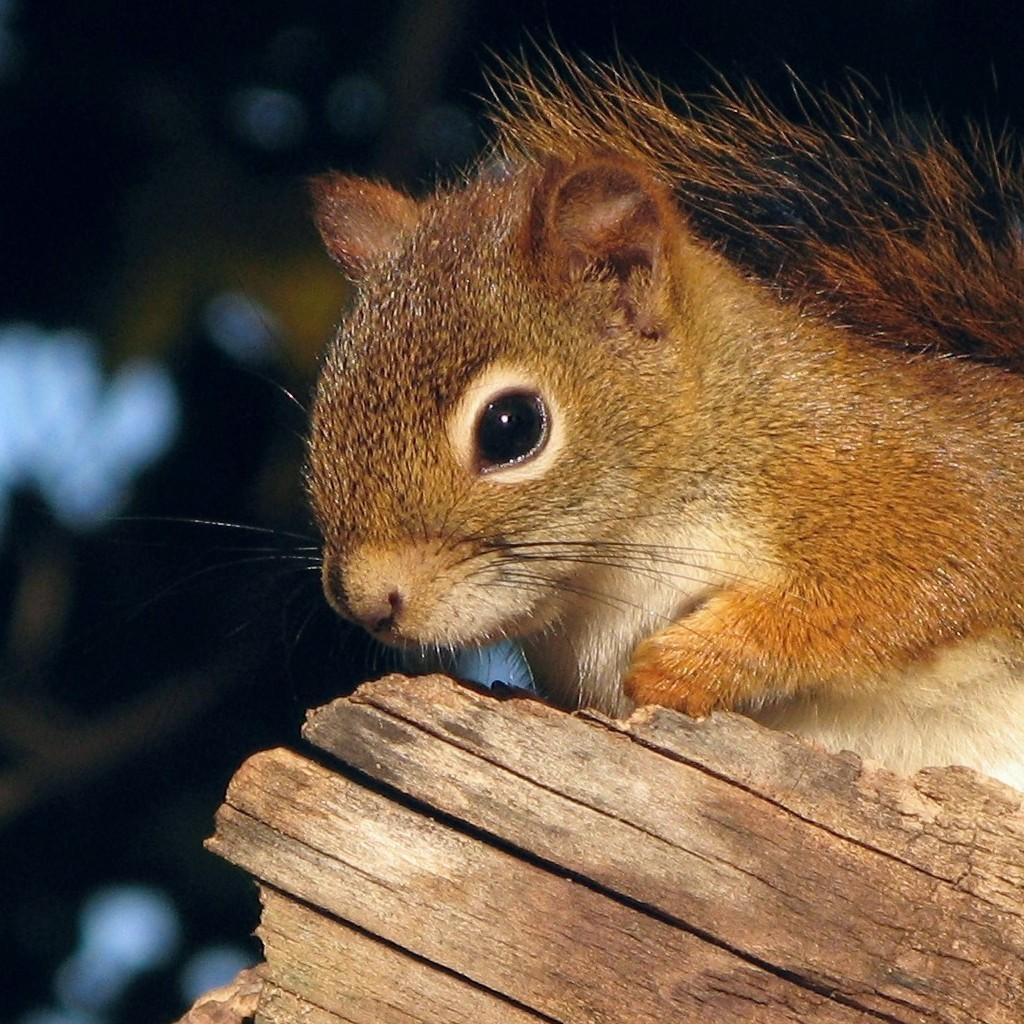Could you give a brief overview of what you see in this image? In this image we can see a squirrel on the wooden block. 